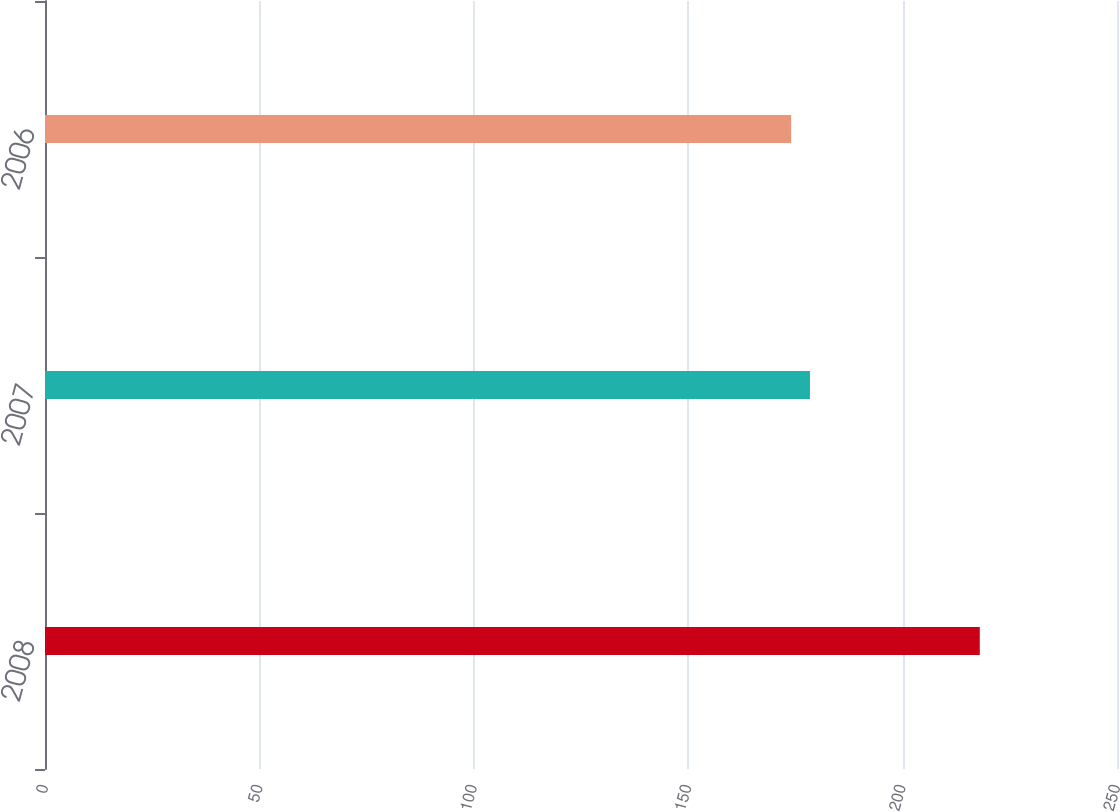Convert chart to OTSL. <chart><loc_0><loc_0><loc_500><loc_500><bar_chart><fcel>2008<fcel>2007<fcel>2006<nl><fcel>218<fcel>178.4<fcel>174<nl></chart> 